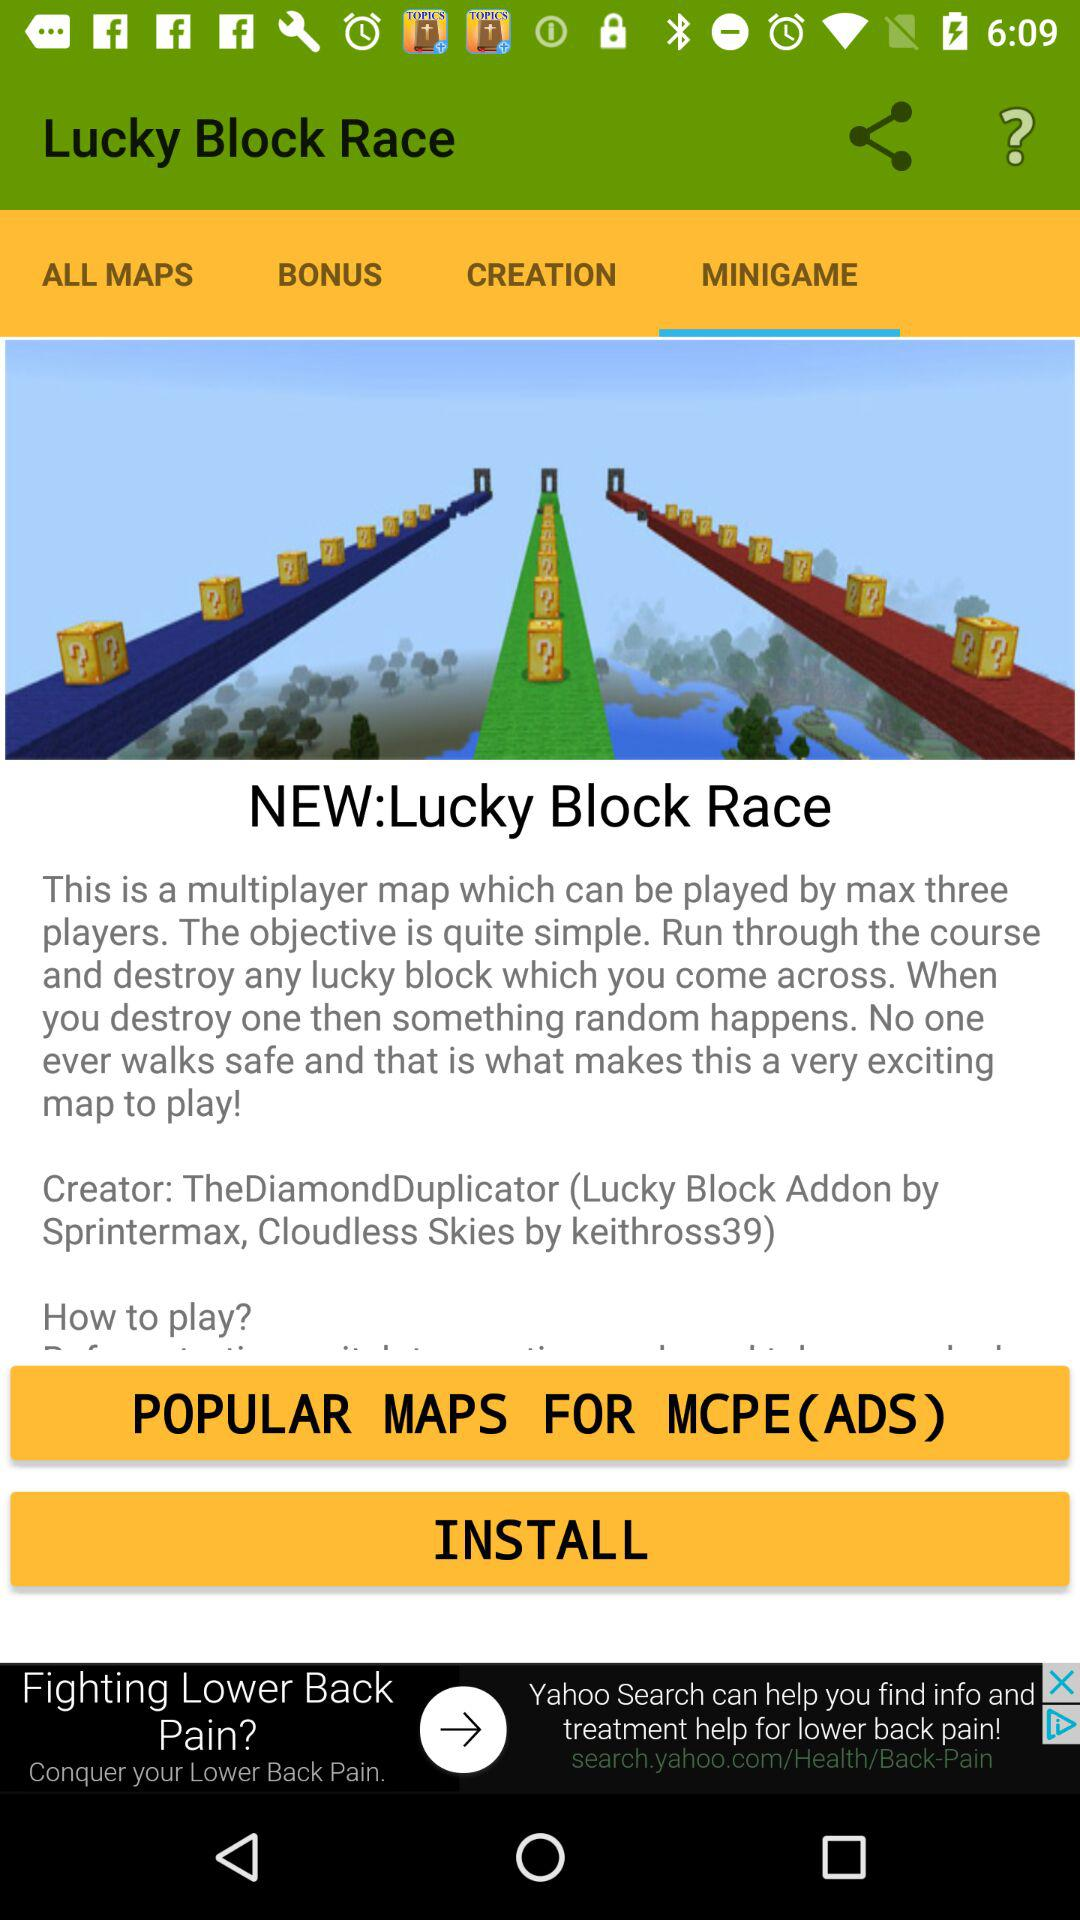Which tab am I using? You are using the tab "MINIGAME". 